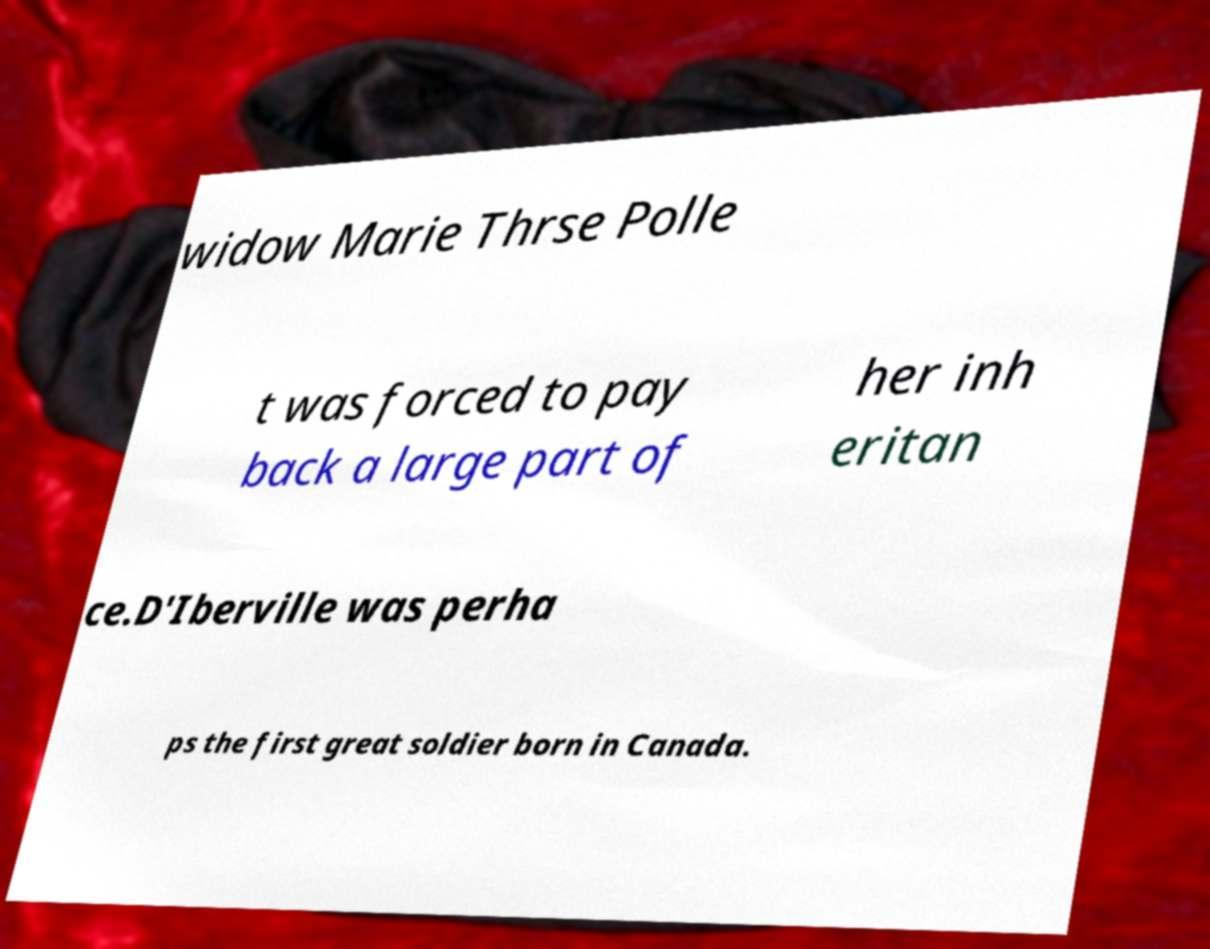I need the written content from this picture converted into text. Can you do that? widow Marie Thrse Polle t was forced to pay back a large part of her inh eritan ce.D'Iberville was perha ps the first great soldier born in Canada. 